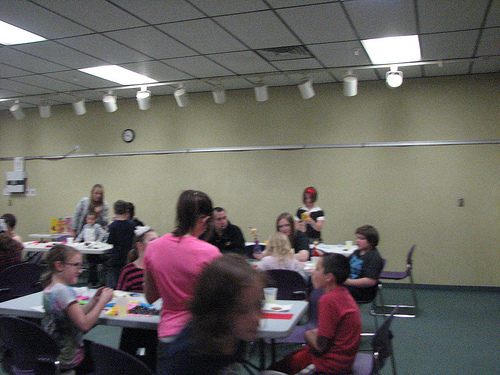<image>
Is the woman back to the left of the woman front? No. The woman back is not to the left of the woman front. From this viewpoint, they have a different horizontal relationship. Where is the girl in relation to the table? Is it behind the table? No. The girl is not behind the table. From this viewpoint, the girl appears to be positioned elsewhere in the scene. 